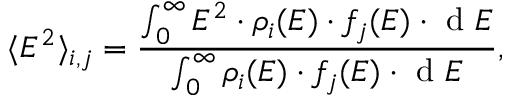<formula> <loc_0><loc_0><loc_500><loc_500>\langle E ^ { 2 } \rangle _ { i , j } = \frac { \int _ { 0 } ^ { \infty } E ^ { 2 } \cdot \rho _ { i } ( E ) \cdot f _ { j } ( E ) \cdot d E } { \int _ { 0 } ^ { \infty } \rho _ { i } ( E ) \cdot f _ { j } ( E ) \cdot d E } ,</formula> 